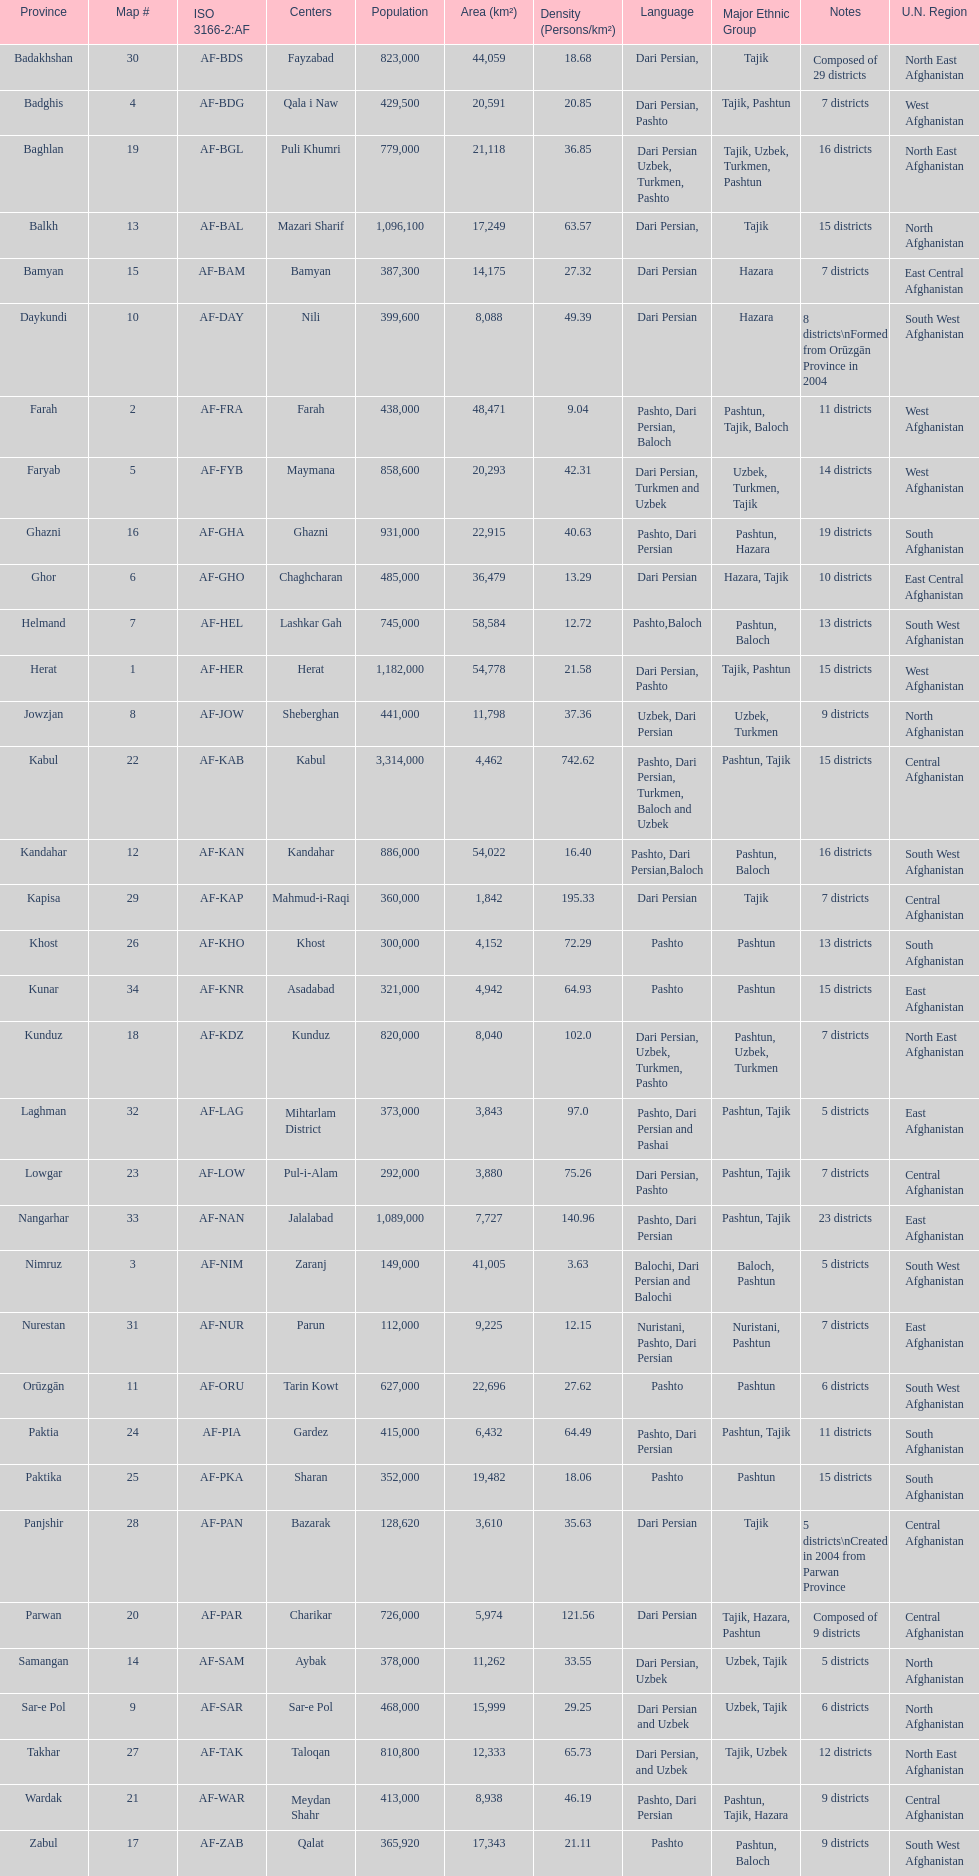How many provinces in afghanistan speak dari persian? 28. 